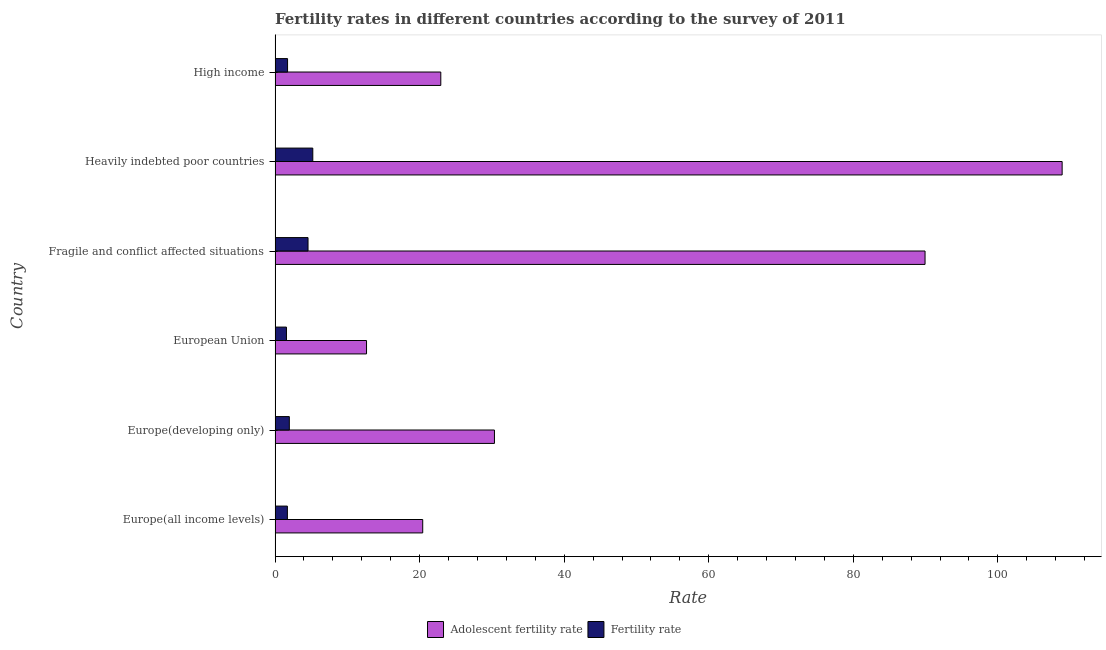How many different coloured bars are there?
Your answer should be very brief. 2. Are the number of bars on each tick of the Y-axis equal?
Make the answer very short. Yes. How many bars are there on the 4th tick from the bottom?
Give a very brief answer. 2. What is the adolescent fertility rate in Heavily indebted poor countries?
Your answer should be very brief. 108.9. Across all countries, what is the maximum fertility rate?
Make the answer very short. 5.22. Across all countries, what is the minimum adolescent fertility rate?
Keep it short and to the point. 12.65. In which country was the adolescent fertility rate maximum?
Keep it short and to the point. Heavily indebted poor countries. What is the total fertility rate in the graph?
Ensure brevity in your answer.  16.75. What is the difference between the adolescent fertility rate in European Union and that in Fragile and conflict affected situations?
Provide a short and direct response. -77.28. What is the difference between the fertility rate in Europe(developing only) and the adolescent fertility rate in Europe(all income levels)?
Offer a terse response. -18.46. What is the average adolescent fertility rate per country?
Offer a very short reply. 47.53. What is the difference between the adolescent fertility rate and fertility rate in Heavily indebted poor countries?
Your answer should be very brief. 103.68. What is the ratio of the fertility rate in Fragile and conflict affected situations to that in High income?
Keep it short and to the point. 2.64. Is the difference between the fertility rate in Europe(all income levels) and Europe(developing only) greater than the difference between the adolescent fertility rate in Europe(all income levels) and Europe(developing only)?
Give a very brief answer. Yes. What is the difference between the highest and the second highest adolescent fertility rate?
Offer a terse response. 18.97. What is the difference between the highest and the lowest adolescent fertility rate?
Ensure brevity in your answer.  96.25. Is the sum of the adolescent fertility rate in Europe(developing only) and European Union greater than the maximum fertility rate across all countries?
Your answer should be very brief. Yes. What does the 1st bar from the top in European Union represents?
Give a very brief answer. Fertility rate. What does the 1st bar from the bottom in High income represents?
Give a very brief answer. Adolescent fertility rate. How many bars are there?
Provide a short and direct response. 12. Are all the bars in the graph horizontal?
Keep it short and to the point. Yes. Are the values on the major ticks of X-axis written in scientific E-notation?
Make the answer very short. No. Does the graph contain any zero values?
Make the answer very short. No. Does the graph contain grids?
Make the answer very short. No. Where does the legend appear in the graph?
Offer a very short reply. Bottom center. How are the legend labels stacked?
Ensure brevity in your answer.  Horizontal. What is the title of the graph?
Provide a succinct answer. Fertility rates in different countries according to the survey of 2011. Does "Constant 2005 US$" appear as one of the legend labels in the graph?
Provide a short and direct response. No. What is the label or title of the X-axis?
Provide a short and direct response. Rate. What is the label or title of the Y-axis?
Make the answer very short. Country. What is the Rate of Adolescent fertility rate in Europe(all income levels)?
Make the answer very short. 20.43. What is the Rate of Fertility rate in Europe(all income levels)?
Your response must be concise. 1.7. What is the Rate in Adolescent fertility rate in Europe(developing only)?
Offer a terse response. 30.35. What is the Rate in Fertility rate in Europe(developing only)?
Give a very brief answer. 1.97. What is the Rate of Adolescent fertility rate in European Union?
Provide a succinct answer. 12.65. What is the Rate of Fertility rate in European Union?
Offer a very short reply. 1.57. What is the Rate in Adolescent fertility rate in Fragile and conflict affected situations?
Offer a very short reply. 89.93. What is the Rate in Fertility rate in Fragile and conflict affected situations?
Give a very brief answer. 4.56. What is the Rate in Adolescent fertility rate in Heavily indebted poor countries?
Keep it short and to the point. 108.9. What is the Rate in Fertility rate in Heavily indebted poor countries?
Ensure brevity in your answer.  5.22. What is the Rate of Adolescent fertility rate in High income?
Your response must be concise. 22.93. What is the Rate of Fertility rate in High income?
Your response must be concise. 1.73. Across all countries, what is the maximum Rate in Adolescent fertility rate?
Provide a succinct answer. 108.9. Across all countries, what is the maximum Rate of Fertility rate?
Your answer should be compact. 5.22. Across all countries, what is the minimum Rate of Adolescent fertility rate?
Your answer should be very brief. 12.65. Across all countries, what is the minimum Rate of Fertility rate?
Ensure brevity in your answer.  1.57. What is the total Rate of Adolescent fertility rate in the graph?
Your response must be concise. 285.19. What is the total Rate of Fertility rate in the graph?
Ensure brevity in your answer.  16.75. What is the difference between the Rate of Adolescent fertility rate in Europe(all income levels) and that in Europe(developing only)?
Ensure brevity in your answer.  -9.92. What is the difference between the Rate of Fertility rate in Europe(all income levels) and that in Europe(developing only)?
Provide a short and direct response. -0.27. What is the difference between the Rate in Adolescent fertility rate in Europe(all income levels) and that in European Union?
Your answer should be compact. 7.77. What is the difference between the Rate of Fertility rate in Europe(all income levels) and that in European Union?
Keep it short and to the point. 0.13. What is the difference between the Rate in Adolescent fertility rate in Europe(all income levels) and that in Fragile and conflict affected situations?
Keep it short and to the point. -69.5. What is the difference between the Rate in Fertility rate in Europe(all income levels) and that in Fragile and conflict affected situations?
Provide a short and direct response. -2.86. What is the difference between the Rate in Adolescent fertility rate in Europe(all income levels) and that in Heavily indebted poor countries?
Make the answer very short. -88.47. What is the difference between the Rate of Fertility rate in Europe(all income levels) and that in Heavily indebted poor countries?
Your answer should be very brief. -3.52. What is the difference between the Rate in Adolescent fertility rate in Europe(all income levels) and that in High income?
Offer a very short reply. -2.5. What is the difference between the Rate of Fertility rate in Europe(all income levels) and that in High income?
Give a very brief answer. -0.02. What is the difference between the Rate in Adolescent fertility rate in Europe(developing only) and that in European Union?
Make the answer very short. 17.7. What is the difference between the Rate of Fertility rate in Europe(developing only) and that in European Union?
Provide a succinct answer. 0.4. What is the difference between the Rate of Adolescent fertility rate in Europe(developing only) and that in Fragile and conflict affected situations?
Your answer should be very brief. -59.58. What is the difference between the Rate of Fertility rate in Europe(developing only) and that in Fragile and conflict affected situations?
Make the answer very short. -2.59. What is the difference between the Rate of Adolescent fertility rate in Europe(developing only) and that in Heavily indebted poor countries?
Offer a very short reply. -78.55. What is the difference between the Rate of Fertility rate in Europe(developing only) and that in Heavily indebted poor countries?
Keep it short and to the point. -3.25. What is the difference between the Rate in Adolescent fertility rate in Europe(developing only) and that in High income?
Give a very brief answer. 7.42. What is the difference between the Rate in Fertility rate in Europe(developing only) and that in High income?
Make the answer very short. 0.25. What is the difference between the Rate in Adolescent fertility rate in European Union and that in Fragile and conflict affected situations?
Your response must be concise. -77.28. What is the difference between the Rate in Fertility rate in European Union and that in Fragile and conflict affected situations?
Offer a very short reply. -2.98. What is the difference between the Rate of Adolescent fertility rate in European Union and that in Heavily indebted poor countries?
Your answer should be very brief. -96.25. What is the difference between the Rate of Fertility rate in European Union and that in Heavily indebted poor countries?
Your answer should be very brief. -3.64. What is the difference between the Rate of Adolescent fertility rate in European Union and that in High income?
Provide a short and direct response. -10.28. What is the difference between the Rate in Fertility rate in European Union and that in High income?
Your answer should be very brief. -0.15. What is the difference between the Rate in Adolescent fertility rate in Fragile and conflict affected situations and that in Heavily indebted poor countries?
Ensure brevity in your answer.  -18.97. What is the difference between the Rate in Fertility rate in Fragile and conflict affected situations and that in Heavily indebted poor countries?
Make the answer very short. -0.66. What is the difference between the Rate in Adolescent fertility rate in Fragile and conflict affected situations and that in High income?
Your answer should be very brief. 67. What is the difference between the Rate of Fertility rate in Fragile and conflict affected situations and that in High income?
Your response must be concise. 2.83. What is the difference between the Rate in Adolescent fertility rate in Heavily indebted poor countries and that in High income?
Give a very brief answer. 85.97. What is the difference between the Rate in Fertility rate in Heavily indebted poor countries and that in High income?
Give a very brief answer. 3.49. What is the difference between the Rate in Adolescent fertility rate in Europe(all income levels) and the Rate in Fertility rate in Europe(developing only)?
Give a very brief answer. 18.46. What is the difference between the Rate of Adolescent fertility rate in Europe(all income levels) and the Rate of Fertility rate in European Union?
Make the answer very short. 18.85. What is the difference between the Rate in Adolescent fertility rate in Europe(all income levels) and the Rate in Fertility rate in Fragile and conflict affected situations?
Provide a short and direct response. 15.87. What is the difference between the Rate in Adolescent fertility rate in Europe(all income levels) and the Rate in Fertility rate in Heavily indebted poor countries?
Offer a very short reply. 15.21. What is the difference between the Rate of Adolescent fertility rate in Europe(all income levels) and the Rate of Fertility rate in High income?
Your response must be concise. 18.7. What is the difference between the Rate of Adolescent fertility rate in Europe(developing only) and the Rate of Fertility rate in European Union?
Provide a short and direct response. 28.78. What is the difference between the Rate in Adolescent fertility rate in Europe(developing only) and the Rate in Fertility rate in Fragile and conflict affected situations?
Provide a short and direct response. 25.79. What is the difference between the Rate in Adolescent fertility rate in Europe(developing only) and the Rate in Fertility rate in Heavily indebted poor countries?
Your response must be concise. 25.13. What is the difference between the Rate of Adolescent fertility rate in Europe(developing only) and the Rate of Fertility rate in High income?
Offer a very short reply. 28.63. What is the difference between the Rate in Adolescent fertility rate in European Union and the Rate in Fertility rate in Fragile and conflict affected situations?
Keep it short and to the point. 8.1. What is the difference between the Rate of Adolescent fertility rate in European Union and the Rate of Fertility rate in Heavily indebted poor countries?
Offer a terse response. 7.43. What is the difference between the Rate of Adolescent fertility rate in European Union and the Rate of Fertility rate in High income?
Your answer should be very brief. 10.93. What is the difference between the Rate of Adolescent fertility rate in Fragile and conflict affected situations and the Rate of Fertility rate in Heavily indebted poor countries?
Keep it short and to the point. 84.71. What is the difference between the Rate in Adolescent fertility rate in Fragile and conflict affected situations and the Rate in Fertility rate in High income?
Provide a short and direct response. 88.2. What is the difference between the Rate of Adolescent fertility rate in Heavily indebted poor countries and the Rate of Fertility rate in High income?
Keep it short and to the point. 107.17. What is the average Rate of Adolescent fertility rate per country?
Your answer should be very brief. 47.53. What is the average Rate in Fertility rate per country?
Offer a terse response. 2.79. What is the difference between the Rate of Adolescent fertility rate and Rate of Fertility rate in Europe(all income levels)?
Ensure brevity in your answer.  18.73. What is the difference between the Rate in Adolescent fertility rate and Rate in Fertility rate in Europe(developing only)?
Offer a very short reply. 28.38. What is the difference between the Rate of Adolescent fertility rate and Rate of Fertility rate in European Union?
Provide a short and direct response. 11.08. What is the difference between the Rate of Adolescent fertility rate and Rate of Fertility rate in Fragile and conflict affected situations?
Make the answer very short. 85.37. What is the difference between the Rate in Adolescent fertility rate and Rate in Fertility rate in Heavily indebted poor countries?
Provide a succinct answer. 103.68. What is the difference between the Rate in Adolescent fertility rate and Rate in Fertility rate in High income?
Give a very brief answer. 21.2. What is the ratio of the Rate of Adolescent fertility rate in Europe(all income levels) to that in Europe(developing only)?
Your answer should be compact. 0.67. What is the ratio of the Rate in Fertility rate in Europe(all income levels) to that in Europe(developing only)?
Provide a succinct answer. 0.86. What is the ratio of the Rate in Adolescent fertility rate in Europe(all income levels) to that in European Union?
Your response must be concise. 1.61. What is the ratio of the Rate in Fertility rate in Europe(all income levels) to that in European Union?
Give a very brief answer. 1.08. What is the ratio of the Rate in Adolescent fertility rate in Europe(all income levels) to that in Fragile and conflict affected situations?
Your response must be concise. 0.23. What is the ratio of the Rate in Fertility rate in Europe(all income levels) to that in Fragile and conflict affected situations?
Offer a terse response. 0.37. What is the ratio of the Rate of Adolescent fertility rate in Europe(all income levels) to that in Heavily indebted poor countries?
Offer a very short reply. 0.19. What is the ratio of the Rate in Fertility rate in Europe(all income levels) to that in Heavily indebted poor countries?
Offer a terse response. 0.33. What is the ratio of the Rate in Adolescent fertility rate in Europe(all income levels) to that in High income?
Offer a very short reply. 0.89. What is the ratio of the Rate in Fertility rate in Europe(all income levels) to that in High income?
Provide a succinct answer. 0.99. What is the ratio of the Rate of Adolescent fertility rate in Europe(developing only) to that in European Union?
Your answer should be compact. 2.4. What is the ratio of the Rate of Fertility rate in Europe(developing only) to that in European Union?
Offer a very short reply. 1.25. What is the ratio of the Rate of Adolescent fertility rate in Europe(developing only) to that in Fragile and conflict affected situations?
Keep it short and to the point. 0.34. What is the ratio of the Rate in Fertility rate in Europe(developing only) to that in Fragile and conflict affected situations?
Keep it short and to the point. 0.43. What is the ratio of the Rate in Adolescent fertility rate in Europe(developing only) to that in Heavily indebted poor countries?
Offer a terse response. 0.28. What is the ratio of the Rate in Fertility rate in Europe(developing only) to that in Heavily indebted poor countries?
Keep it short and to the point. 0.38. What is the ratio of the Rate of Adolescent fertility rate in Europe(developing only) to that in High income?
Your answer should be very brief. 1.32. What is the ratio of the Rate in Fertility rate in Europe(developing only) to that in High income?
Provide a succinct answer. 1.14. What is the ratio of the Rate of Adolescent fertility rate in European Union to that in Fragile and conflict affected situations?
Offer a terse response. 0.14. What is the ratio of the Rate of Fertility rate in European Union to that in Fragile and conflict affected situations?
Your answer should be compact. 0.35. What is the ratio of the Rate of Adolescent fertility rate in European Union to that in Heavily indebted poor countries?
Offer a terse response. 0.12. What is the ratio of the Rate of Fertility rate in European Union to that in Heavily indebted poor countries?
Offer a terse response. 0.3. What is the ratio of the Rate in Adolescent fertility rate in European Union to that in High income?
Offer a terse response. 0.55. What is the ratio of the Rate of Fertility rate in European Union to that in High income?
Offer a terse response. 0.91. What is the ratio of the Rate of Adolescent fertility rate in Fragile and conflict affected situations to that in Heavily indebted poor countries?
Provide a succinct answer. 0.83. What is the ratio of the Rate in Fertility rate in Fragile and conflict affected situations to that in Heavily indebted poor countries?
Your answer should be very brief. 0.87. What is the ratio of the Rate of Adolescent fertility rate in Fragile and conflict affected situations to that in High income?
Your response must be concise. 3.92. What is the ratio of the Rate of Fertility rate in Fragile and conflict affected situations to that in High income?
Give a very brief answer. 2.64. What is the ratio of the Rate in Adolescent fertility rate in Heavily indebted poor countries to that in High income?
Your answer should be compact. 4.75. What is the ratio of the Rate of Fertility rate in Heavily indebted poor countries to that in High income?
Your answer should be very brief. 3.02. What is the difference between the highest and the second highest Rate of Adolescent fertility rate?
Your response must be concise. 18.97. What is the difference between the highest and the second highest Rate in Fertility rate?
Make the answer very short. 0.66. What is the difference between the highest and the lowest Rate in Adolescent fertility rate?
Ensure brevity in your answer.  96.25. What is the difference between the highest and the lowest Rate of Fertility rate?
Offer a terse response. 3.64. 